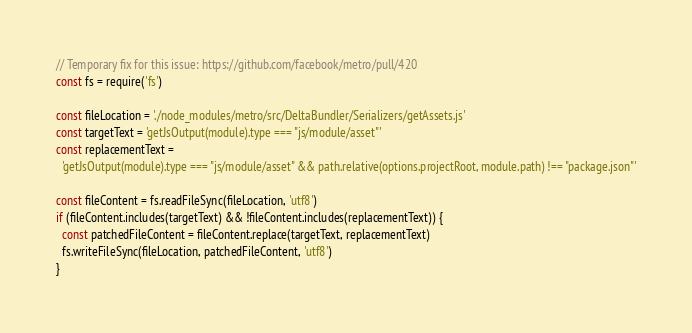<code> <loc_0><loc_0><loc_500><loc_500><_JavaScript_>// Temporary fix for this issue: https://github.com/facebook/metro/pull/420
const fs = require('fs')

const fileLocation = './node_modules/metro/src/DeltaBundler/Serializers/getAssets.js'
const targetText = 'getJsOutput(module).type === "js/module/asset"'
const replacementText =
  'getJsOutput(module).type === "js/module/asset" && path.relative(options.projectRoot, module.path) !== "package.json"'

const fileContent = fs.readFileSync(fileLocation, 'utf8')
if (fileContent.includes(targetText) && !fileContent.includes(replacementText)) {
  const patchedFileContent = fileContent.replace(targetText, replacementText)
  fs.writeFileSync(fileLocation, patchedFileContent, 'utf8')
}
</code> 